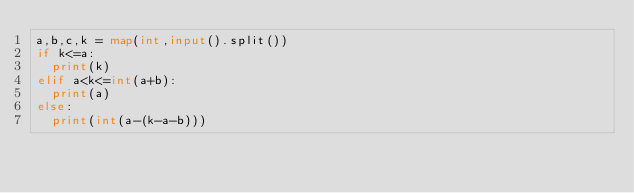<code> <loc_0><loc_0><loc_500><loc_500><_Python_>a,b,c,k = map(int,input().split())
if k<=a:
  print(k)
elif a<k<=int(a+b):
  print(a)
else:
  print(int(a-(k-a-b)))</code> 